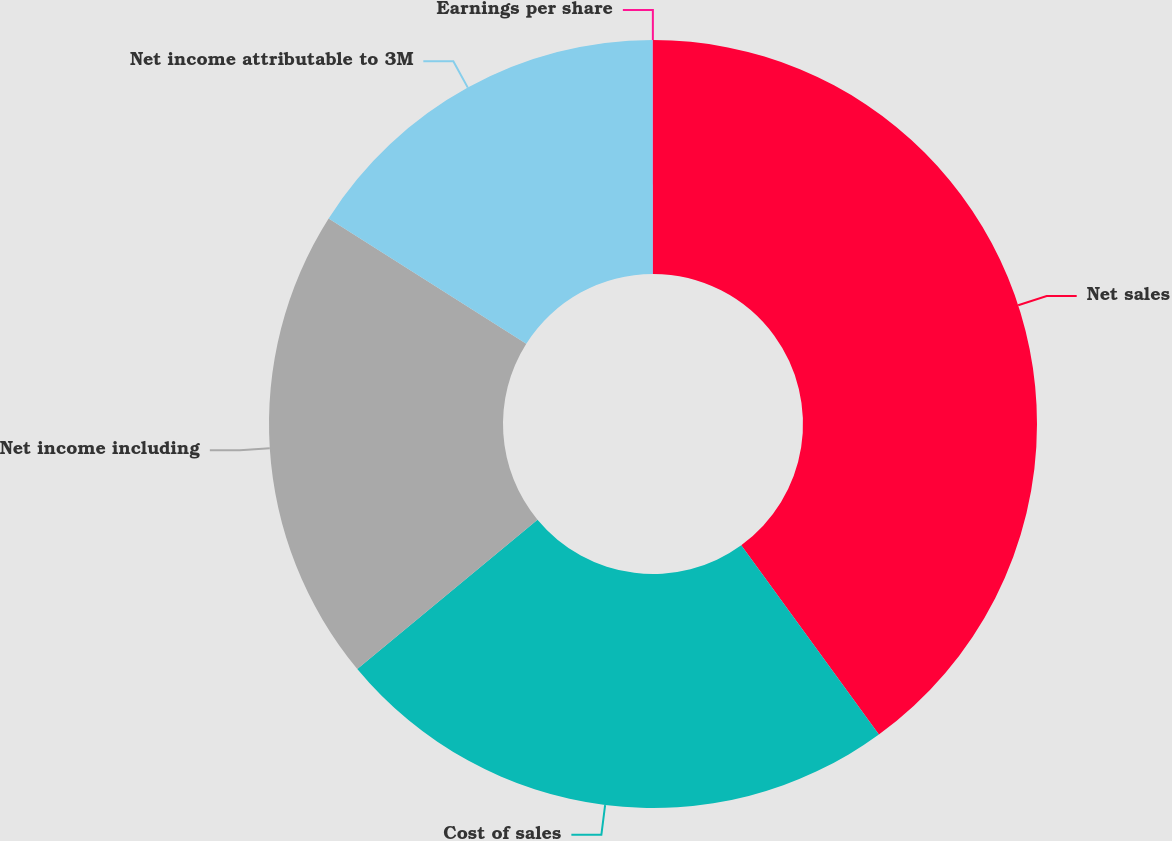Convert chart. <chart><loc_0><loc_0><loc_500><loc_500><pie_chart><fcel>Net sales<fcel>Cost of sales<fcel>Net income including<fcel>Net income attributable to 3M<fcel>Earnings per share<nl><fcel>39.99%<fcel>24.0%<fcel>20.0%<fcel>16.0%<fcel>0.01%<nl></chart> 